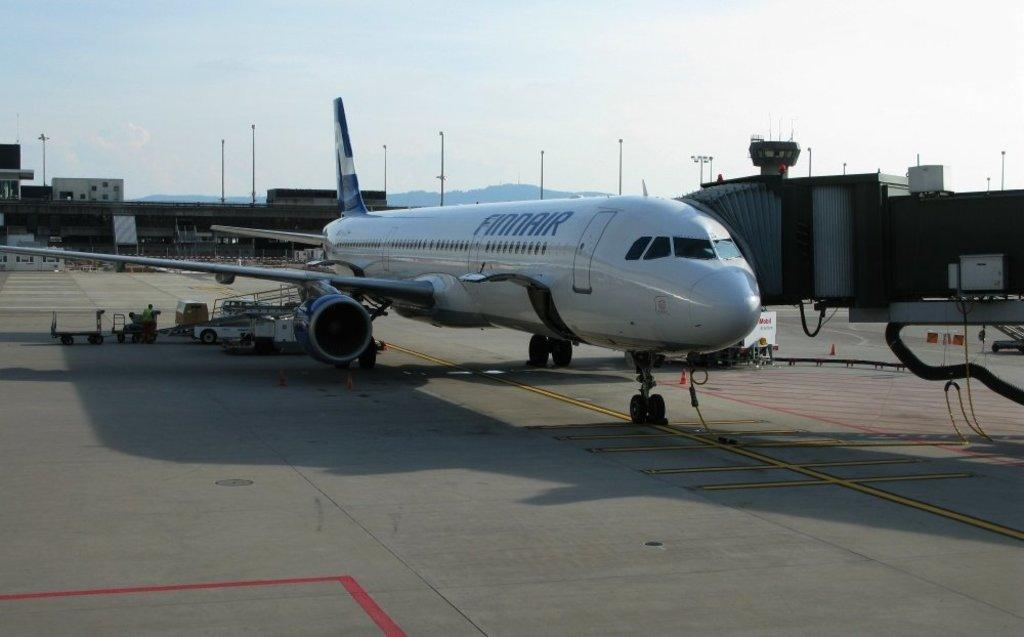What is the main subject of the image? The main subject of the image is an aeroplane. Where is the aeroplane located in the image? The aeroplane is on a runway. What can be seen in the background of the image? There are buildings visible in the background of the image. What is visible above the aeroplane in the image? The sky is visible above the aeroplane. What type of pie is being served to the passengers on the aeroplane in the image? There is no pie or passengers present in the image; it only features an aeroplane on a runway. What color is the gold hook used by the pilot in the image? There is no hook or pilot present in the image; it only features an aeroplane on a runway. 